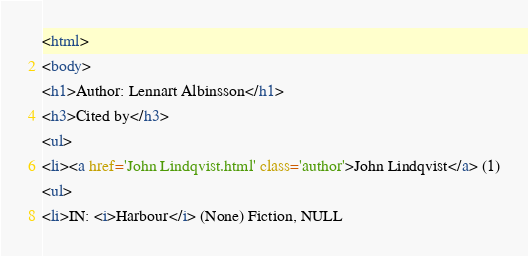<code> <loc_0><loc_0><loc_500><loc_500><_HTML_><html>
<body>
<h1>Author: Lennart Albinsson</h1>
<h3>Cited by</h3>
<ul>
<li><a href='John Lindqvist.html' class='author'>John Lindqvist</a> (1)
<ul>
<li>IN: <i>Harbour</i> (None) Fiction, NULL</code> 